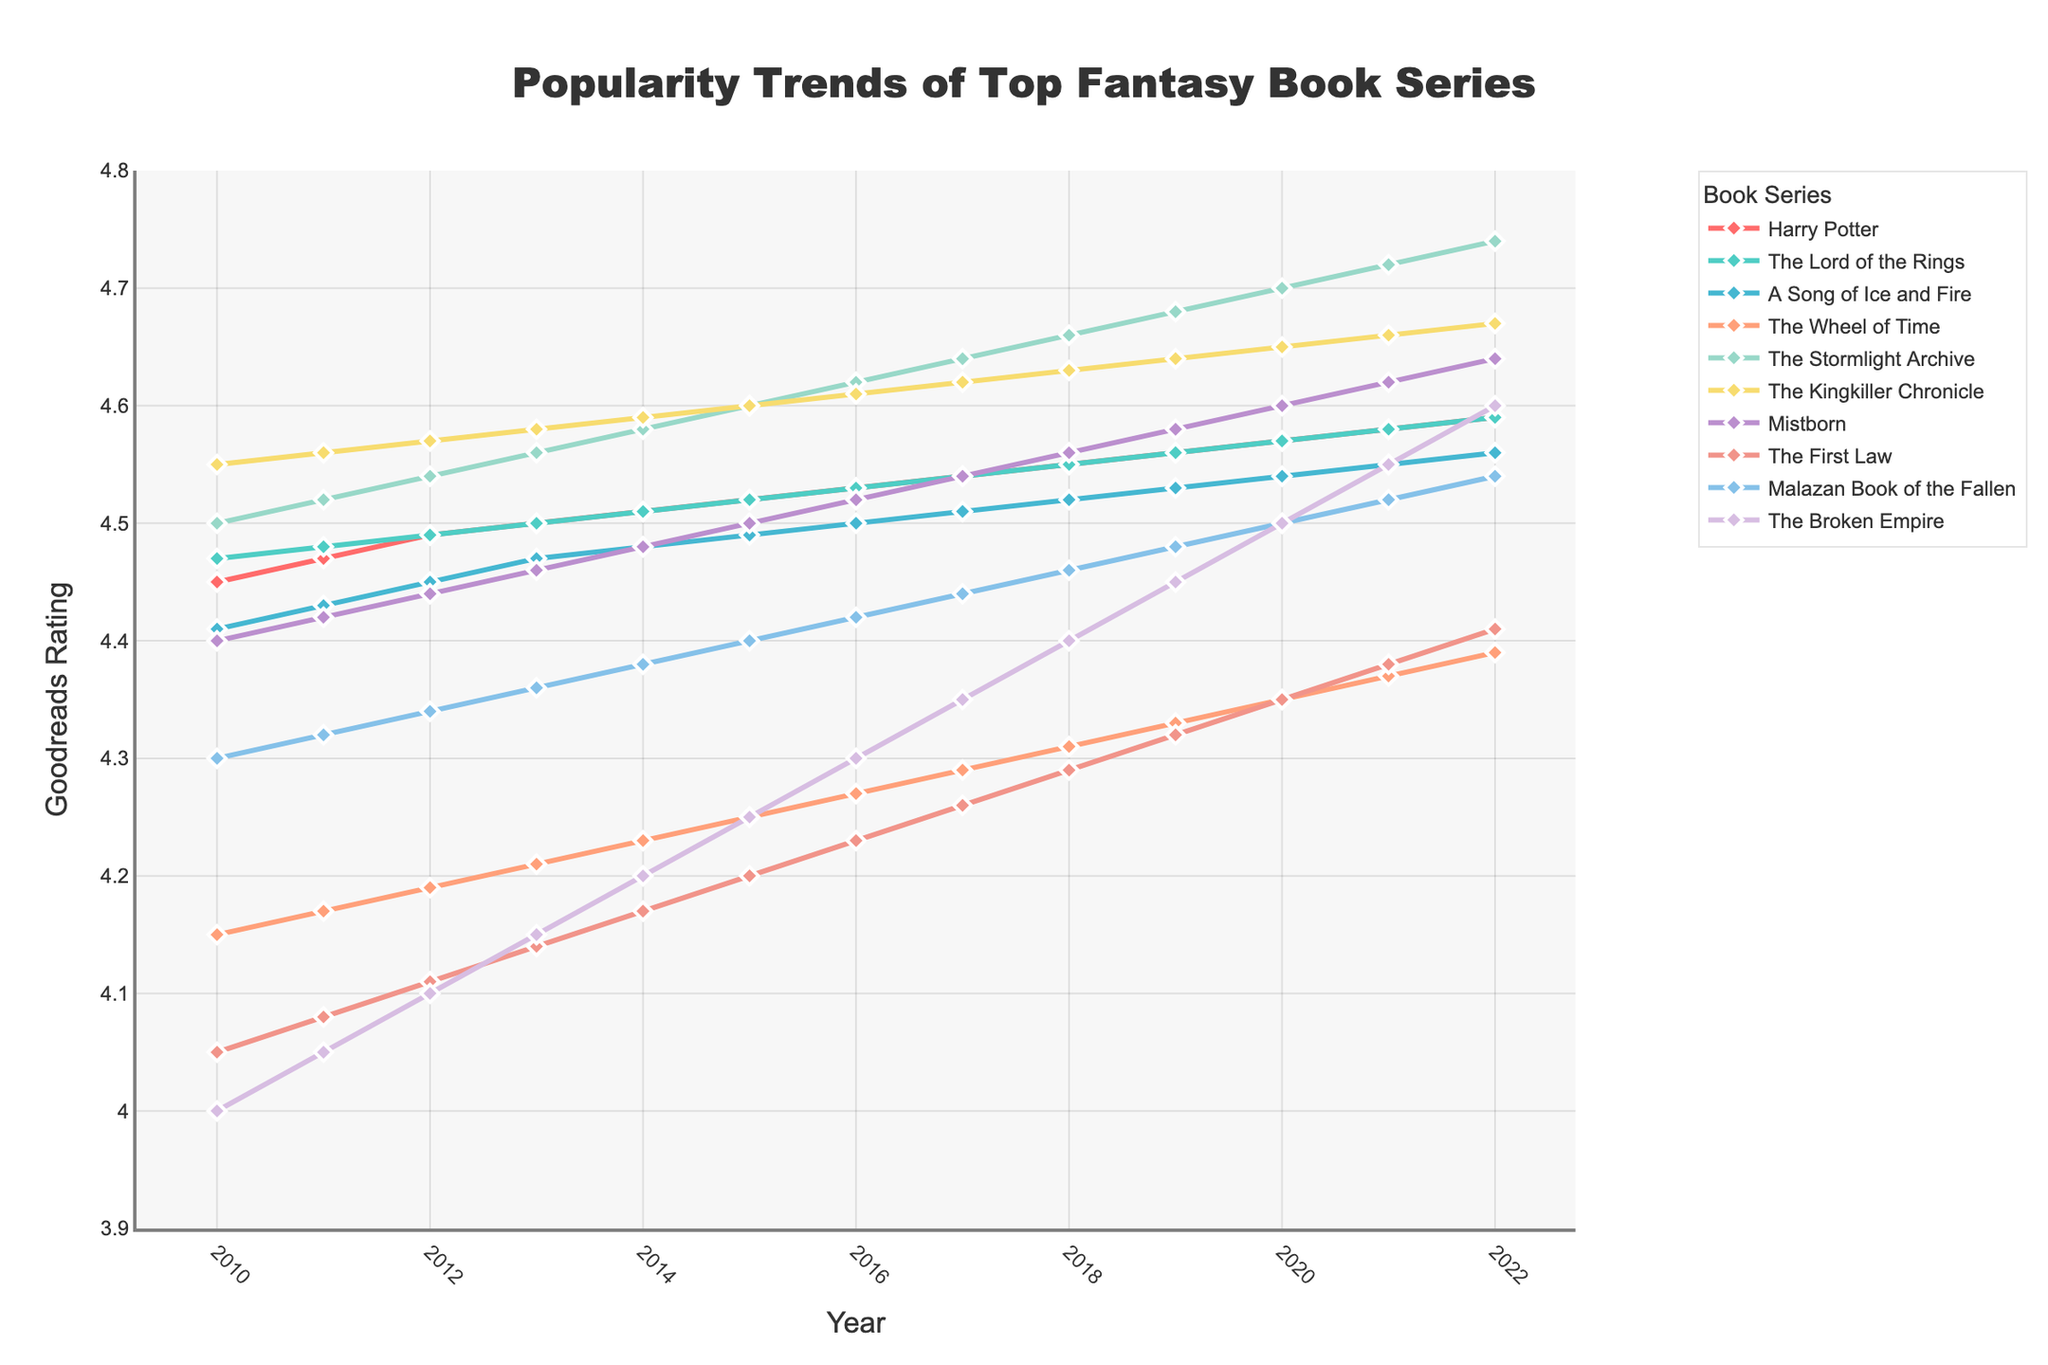Which series has the highest Goodreads rating in 2022? To determine which series has the highest Goodreads rating in 2022, we look at the ratings for that year. The Stormlight Archive has the highest rating at 4.74.
Answer: The Stormlight Archive How did the rating of The Broken Empire change from 2010 to 2022? To determine the change in rating for The Broken Empire from 2010 to 2022, subtract the 2010 rating (4.00) from the 2022 rating (4.60). The change is 4.60 - 4.00 = 0.60.
Answer: Increased by 0.60 Which series had the lowest rating in 2010? To find the series with the lowest rating in 2010, we compare the 2010 ratings for all series. The Broken Empire had the lowest rating at 4.00.
Answer: The Broken Empire Between 2015 and 2016, which series showed the most significant increase in rating? To find the most significant increase, we calculate the difference for each series between 2015 and 2016. The Wheel of Time increased from 4.25 to 4.27 (0.02), The Stormlight Archive increased from 4.60 to 4.62 (0.02), and The Broken Empire from 4.25 to 4.30 (0.05). The Broken Empire had the most significant increase.
Answer: The Broken Empire What is the average rating of Harry Potter over the years 2010 to 2022? To find the average rating, add all the yearly ratings for Harry Potter from 2010 to 2022 and divide by the number of years (13). (4.45 + 4.47 + 4.49 + 4.50 + 4.51 + 4.52 + 4.53 + 4.54 + 4.55 + 4.56 + 4.57 + 4.58 + 4.59) / 13 = 4.525
Answer: 4.525 Which two series had the closest ratings in 2021? Compare the ratings for all series in 2021 to find the closest pair. The Lord of the Rings and Harry Potter both have ratings of 4.58.
Answer: The Lord of the Rings and Harry Potter Over the entire period from 2010 to 2022, which series had the most consistent increase in ratings (steady growth without decreases)? Identify the series that shows a continuous increase in ratings without any decrement. The Harry Potter, The Lord of the Rings, The Stormlight Archive, and The Kingkiller Chronicle all showed consistent increases, but The Stormlight Archive has the largest consistent increase.
Answer: The Stormlight Archive 